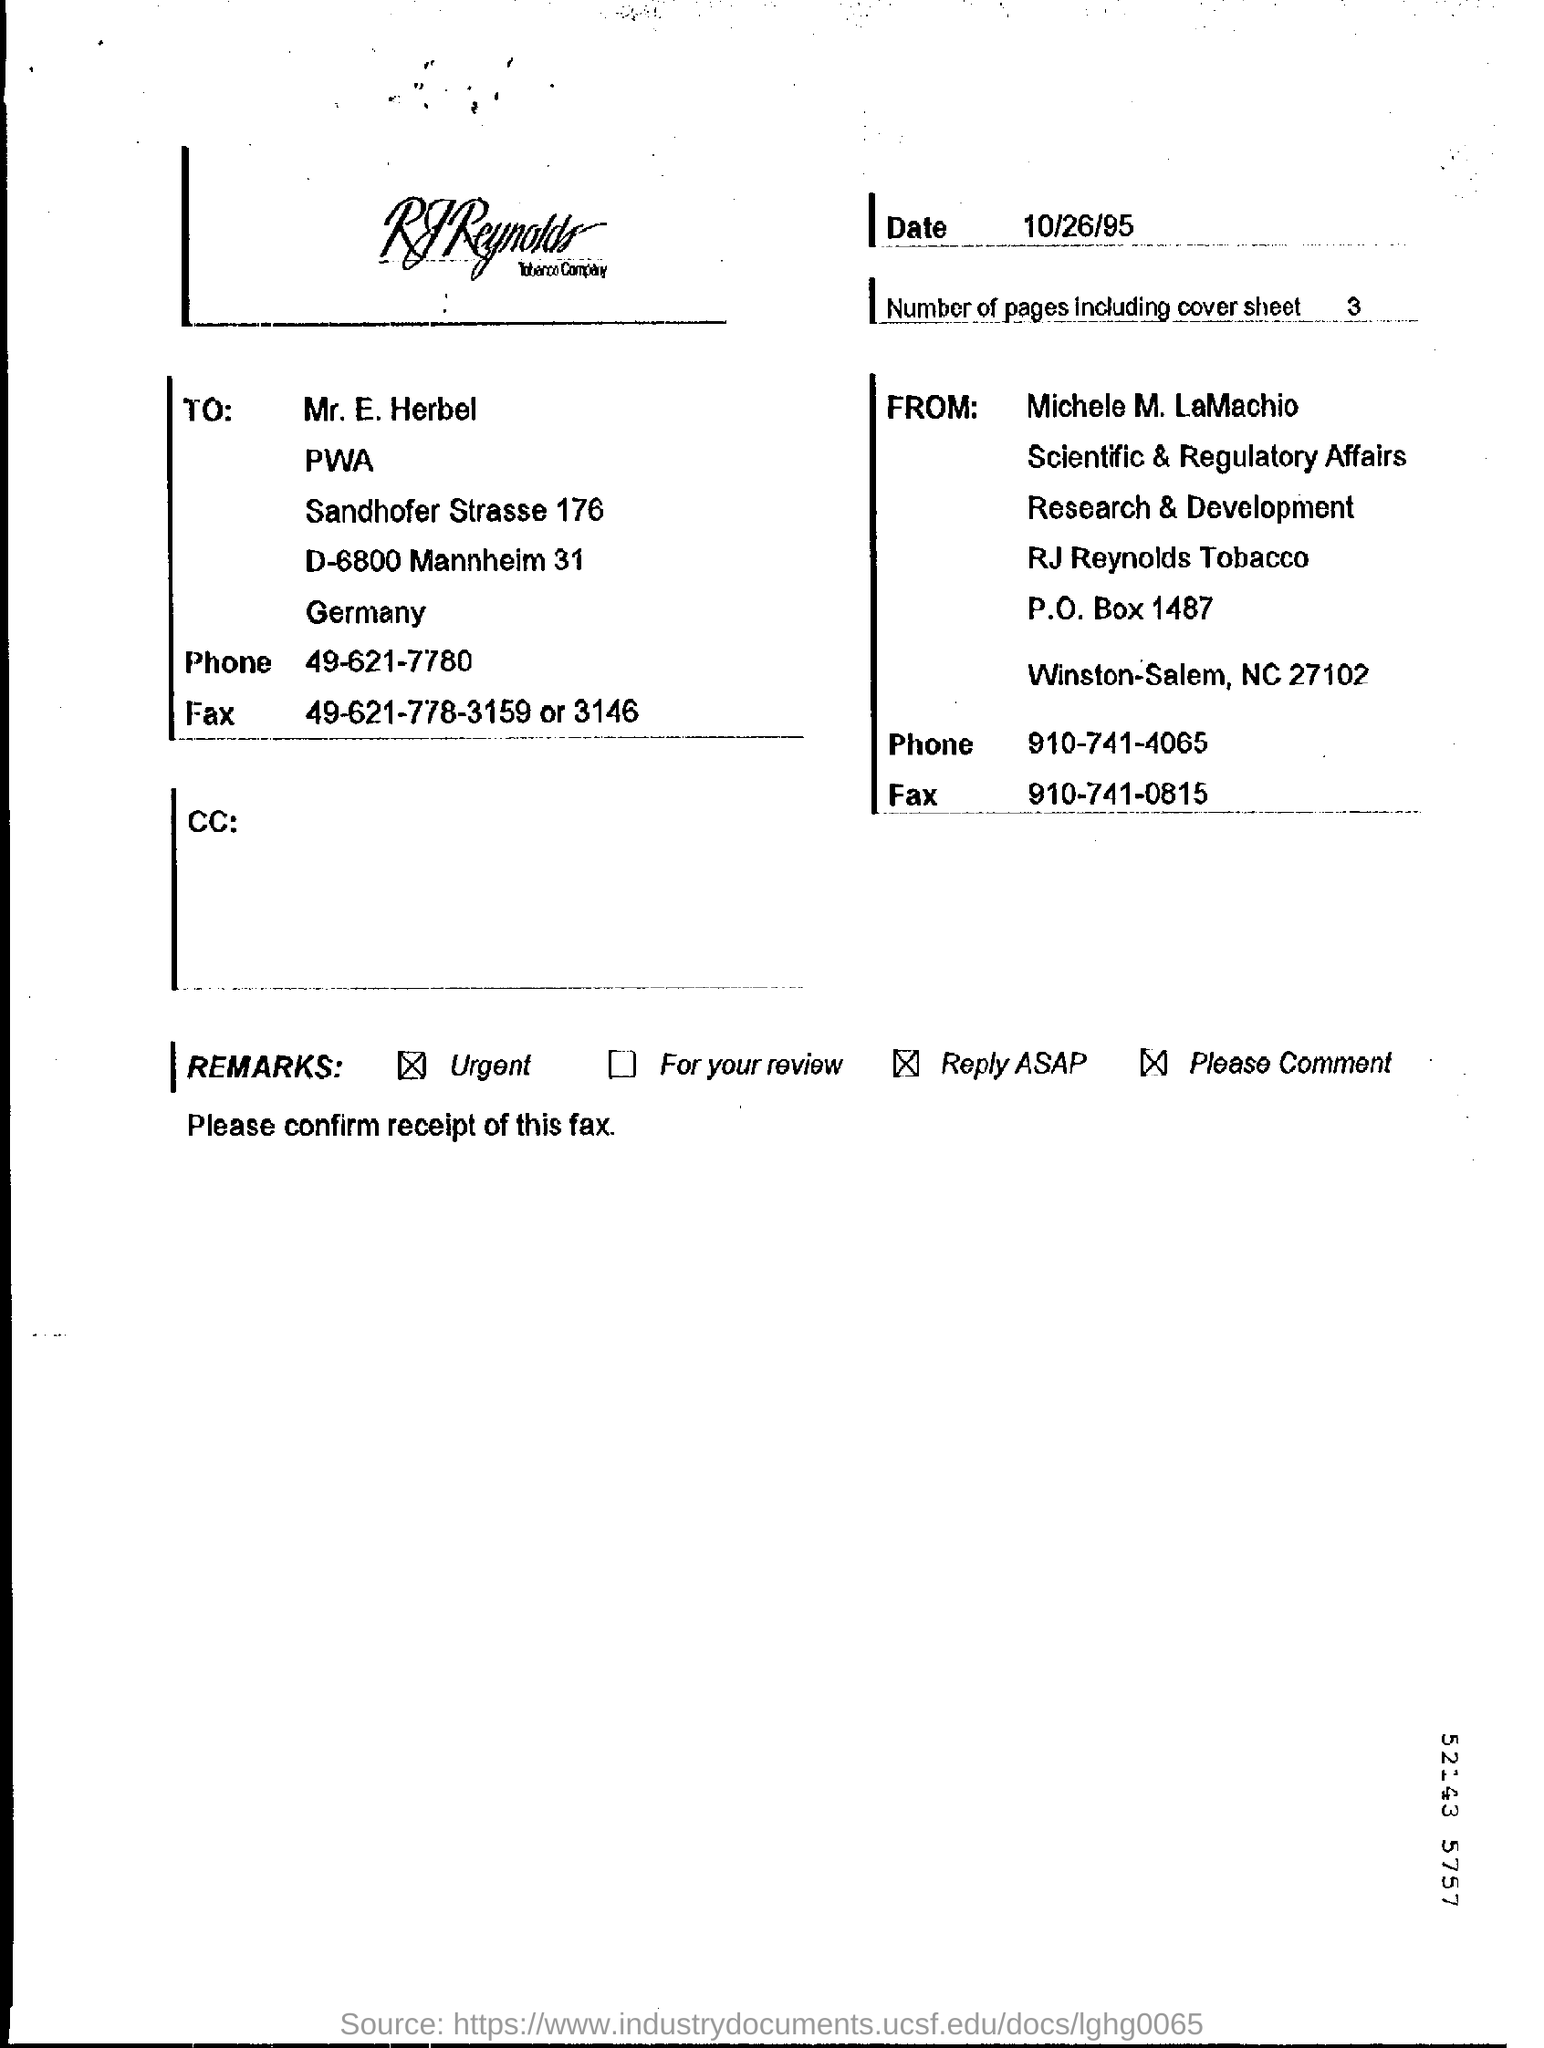Give some essential details in this illustration. The number of pages, including the cover sheet, is three. 